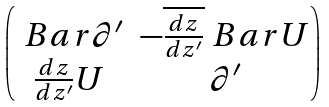Convert formula to latex. <formula><loc_0><loc_0><loc_500><loc_500>\begin{pmatrix} \ B a r { \partial } ^ { \prime } & - \overline { \frac { d z } { d z ^ { \prime } } } \ B a r { U } \\ \frac { d z } { d z ^ { \prime } } U & \partial ^ { \prime } \end{pmatrix}</formula> 